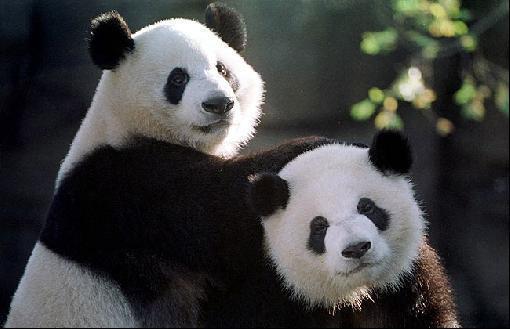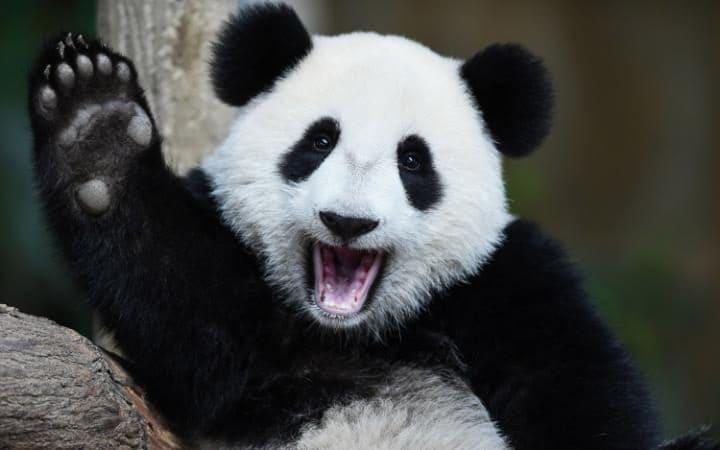The first image is the image on the left, the second image is the image on the right. Analyze the images presented: Is the assertion "There are more panda bears in the left image than in the right." valid? Answer yes or no. Yes. The first image is the image on the left, the second image is the image on the right. Examine the images to the left and right. Is the description "In one of the photos, a panda is eating a bamboo shoot" accurate? Answer yes or no. No. 